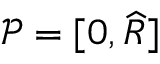<formula> <loc_0><loc_0><loc_500><loc_500>{ \mathcal { P } } = [ 0 , \widehat { R } ]</formula> 